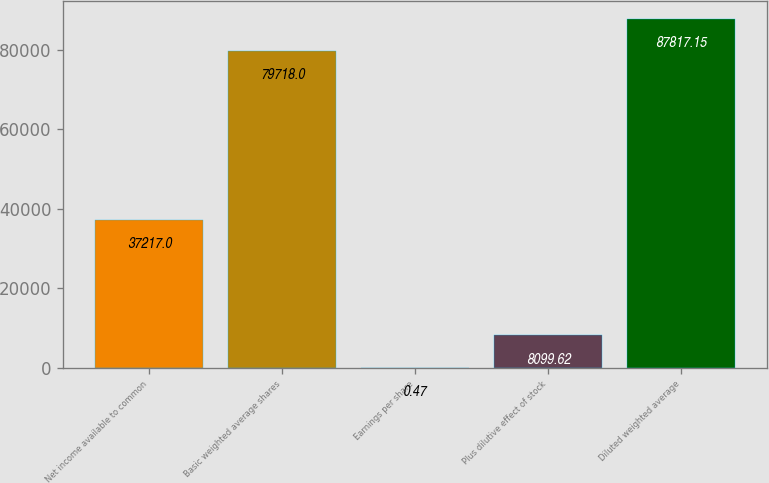Convert chart. <chart><loc_0><loc_0><loc_500><loc_500><bar_chart><fcel>Net income available to common<fcel>Basic weighted average shares<fcel>Earnings per share<fcel>Plus dilutive effect of stock<fcel>Diluted weighted average<nl><fcel>37217<fcel>79718<fcel>0.47<fcel>8099.62<fcel>87817.1<nl></chart> 